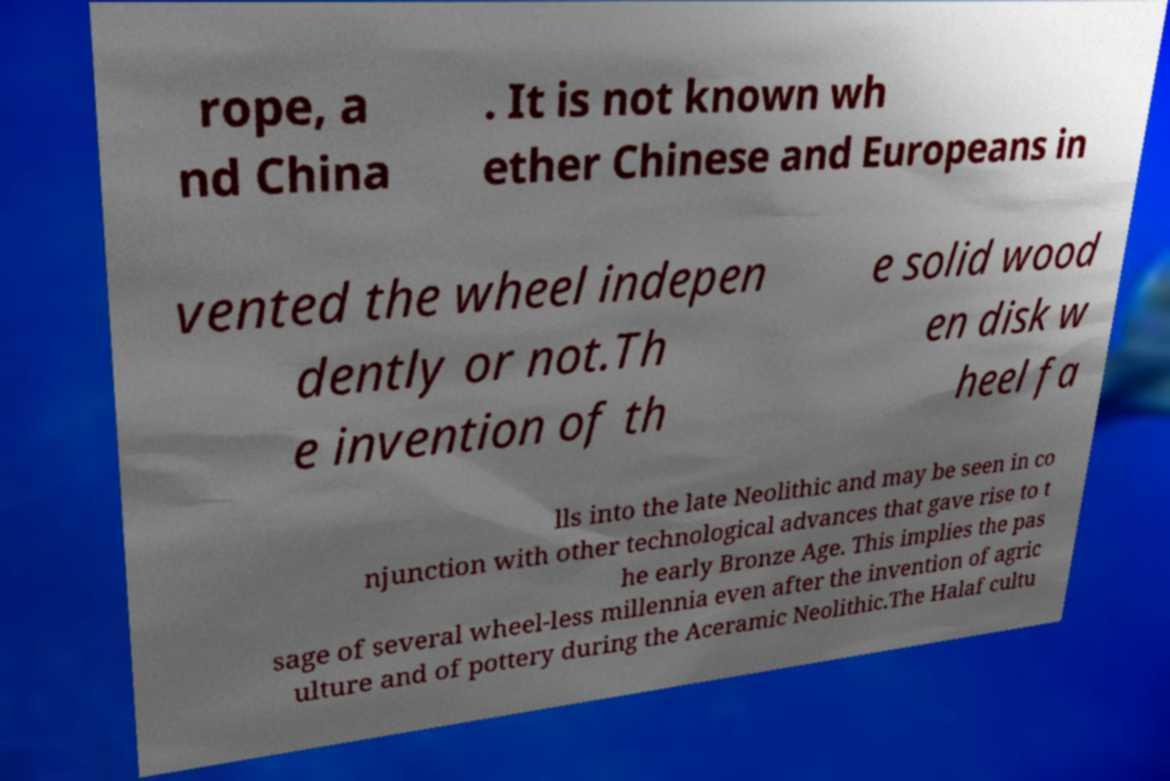I need the written content from this picture converted into text. Can you do that? rope, a nd China . It is not known wh ether Chinese and Europeans in vented the wheel indepen dently or not.Th e invention of th e solid wood en disk w heel fa lls into the late Neolithic and may be seen in co njunction with other technological advances that gave rise to t he early Bronze Age. This implies the pas sage of several wheel-less millennia even after the invention of agric ulture and of pottery during the Aceramic Neolithic.The Halaf cultu 